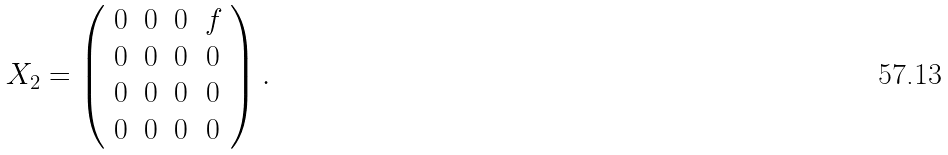Convert formula to latex. <formula><loc_0><loc_0><loc_500><loc_500>X _ { 2 } = \left ( \begin{array} { c c c c } 0 & 0 & 0 & f \\ 0 & 0 & 0 & 0 \\ 0 & 0 & 0 & 0 \\ 0 & 0 & 0 & 0 \end{array} \right ) .</formula> 